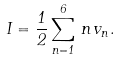Convert formula to latex. <formula><loc_0><loc_0><loc_500><loc_500>I = \frac { 1 } { 2 } \sum _ { n = 1 } ^ { 6 } \, n \, v _ { n } .</formula> 